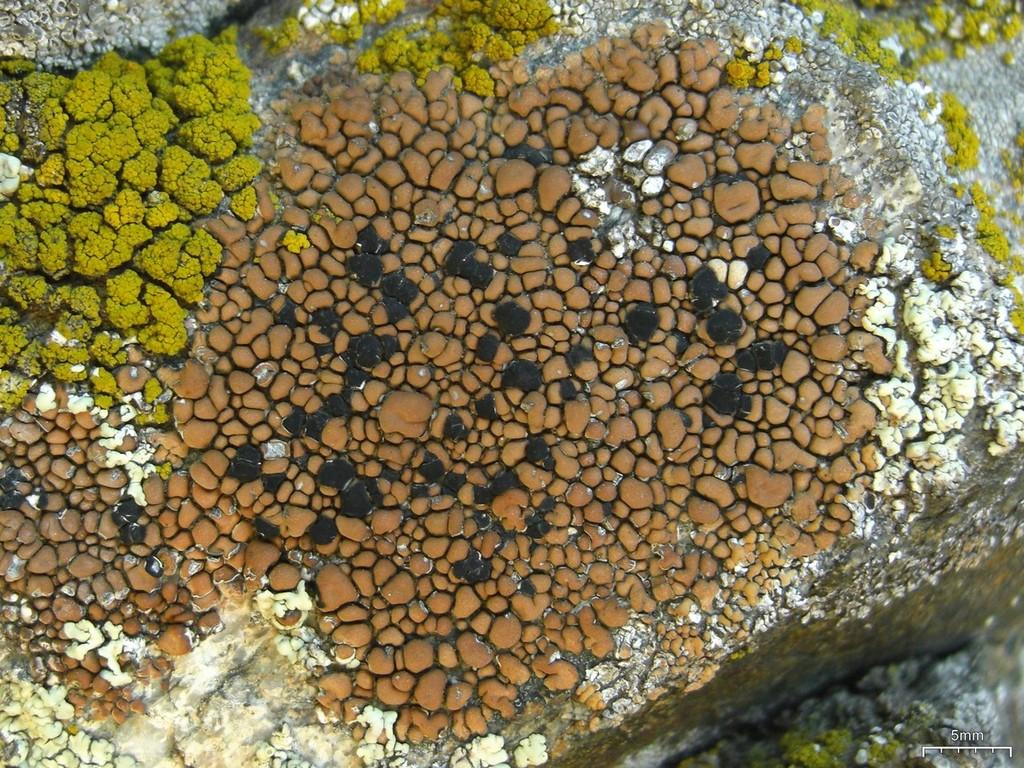What type of objects can be seen in the image? There are stones in the image. What is the color of the stones? The stones are brown in color. What route do the raindrops take as they fall on the stones in the image? There is no rain present in the image, so there are no raindrops falling on the stones. 